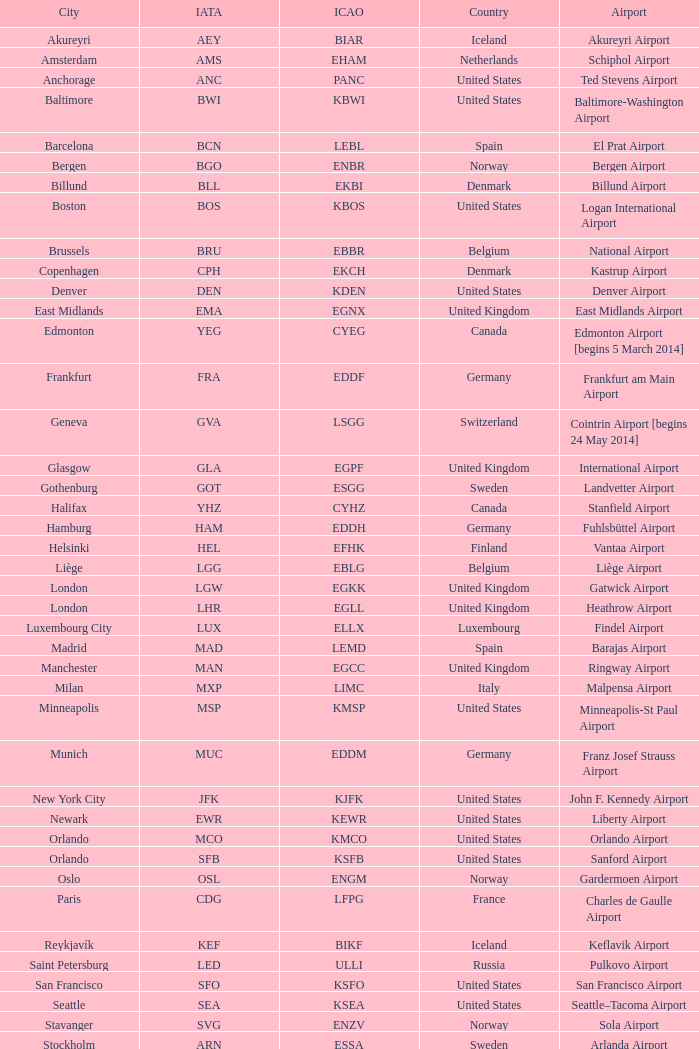What is the IATA OF Akureyri? AEY. Parse the table in full. {'header': ['City', 'IATA', 'ICAO', 'Country', 'Airport'], 'rows': [['Akureyri', 'AEY', 'BIAR', 'Iceland', 'Akureyri Airport'], ['Amsterdam', 'AMS', 'EHAM', 'Netherlands', 'Schiphol Airport'], ['Anchorage', 'ANC', 'PANC', 'United States', 'Ted Stevens Airport'], ['Baltimore', 'BWI', 'KBWI', 'United States', 'Baltimore-Washington Airport'], ['Barcelona', 'BCN', 'LEBL', 'Spain', 'El Prat Airport'], ['Bergen', 'BGO', 'ENBR', 'Norway', 'Bergen Airport'], ['Billund', 'BLL', 'EKBI', 'Denmark', 'Billund Airport'], ['Boston', 'BOS', 'KBOS', 'United States', 'Logan International Airport'], ['Brussels', 'BRU', 'EBBR', 'Belgium', 'National Airport'], ['Copenhagen', 'CPH', 'EKCH', 'Denmark', 'Kastrup Airport'], ['Denver', 'DEN', 'KDEN', 'United States', 'Denver Airport'], ['East Midlands', 'EMA', 'EGNX', 'United Kingdom', 'East Midlands Airport'], ['Edmonton', 'YEG', 'CYEG', 'Canada', 'Edmonton Airport [begins 5 March 2014]'], ['Frankfurt', 'FRA', 'EDDF', 'Germany', 'Frankfurt am Main Airport'], ['Geneva', 'GVA', 'LSGG', 'Switzerland', 'Cointrin Airport [begins 24 May 2014]'], ['Glasgow', 'GLA', 'EGPF', 'United Kingdom', 'International Airport'], ['Gothenburg', 'GOT', 'ESGG', 'Sweden', 'Landvetter Airport'], ['Halifax', 'YHZ', 'CYHZ', 'Canada', 'Stanfield Airport'], ['Hamburg', 'HAM', 'EDDH', 'Germany', 'Fuhlsbüttel Airport'], ['Helsinki', 'HEL', 'EFHK', 'Finland', 'Vantaa Airport'], ['Liège', 'LGG', 'EBLG', 'Belgium', 'Liège Airport'], ['London', 'LGW', 'EGKK', 'United Kingdom', 'Gatwick Airport'], ['London', 'LHR', 'EGLL', 'United Kingdom', 'Heathrow Airport'], ['Luxembourg City', 'LUX', 'ELLX', 'Luxembourg', 'Findel Airport'], ['Madrid', 'MAD', 'LEMD', 'Spain', 'Barajas Airport'], ['Manchester', 'MAN', 'EGCC', 'United Kingdom', 'Ringway Airport'], ['Milan', 'MXP', 'LIMC', 'Italy', 'Malpensa Airport'], ['Minneapolis', 'MSP', 'KMSP', 'United States', 'Minneapolis-St Paul Airport'], ['Munich', 'MUC', 'EDDM', 'Germany', 'Franz Josef Strauss Airport'], ['New York City', 'JFK', 'KJFK', 'United States', 'John F. Kennedy Airport'], ['Newark', 'EWR', 'KEWR', 'United States', 'Liberty Airport'], ['Orlando', 'MCO', 'KMCO', 'United States', 'Orlando Airport'], ['Orlando', 'SFB', 'KSFB', 'United States', 'Sanford Airport'], ['Oslo', 'OSL', 'ENGM', 'Norway', 'Gardermoen Airport'], ['Paris', 'CDG', 'LFPG', 'France', 'Charles de Gaulle Airport'], ['Reykjavík', 'KEF', 'BIKF', 'Iceland', 'Keflavik Airport'], ['Saint Petersburg', 'LED', 'ULLI', 'Russia', 'Pulkovo Airport'], ['San Francisco', 'SFO', 'KSFO', 'United States', 'San Francisco Airport'], ['Seattle', 'SEA', 'KSEA', 'United States', 'Seattle–Tacoma Airport'], ['Stavanger', 'SVG', 'ENZV', 'Norway', 'Sola Airport'], ['Stockholm', 'ARN', 'ESSA', 'Sweden', 'Arlanda Airport'], ['Toronto', 'YYZ', 'CYYZ', 'Canada', 'Pearson Airport'], ['Trondheim', 'TRD', 'ENVA', 'Norway', 'Trondheim Airport'], ['Vancouver', 'YVR', 'CYVR', 'Canada', 'Vancouver Airport [begins 13 May 2014]'], ['Washington, D.C.', 'IAD', 'KIAD', 'United States', 'Dulles Airport'], ['Zurich', 'ZRH', 'LSZH', 'Switzerland', 'Kloten Airport']]} 